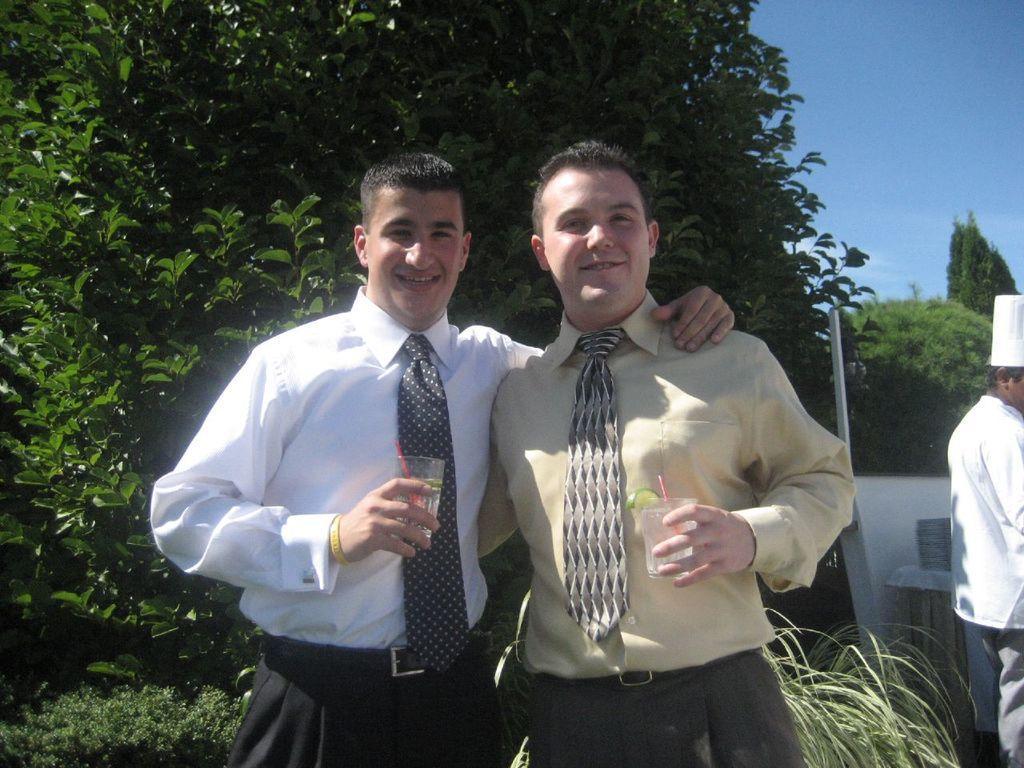How would you summarize this image in a sentence or two? In the image there are two people standing and posing for the photo. On the right side there is a chef and in the background there are many trees. 